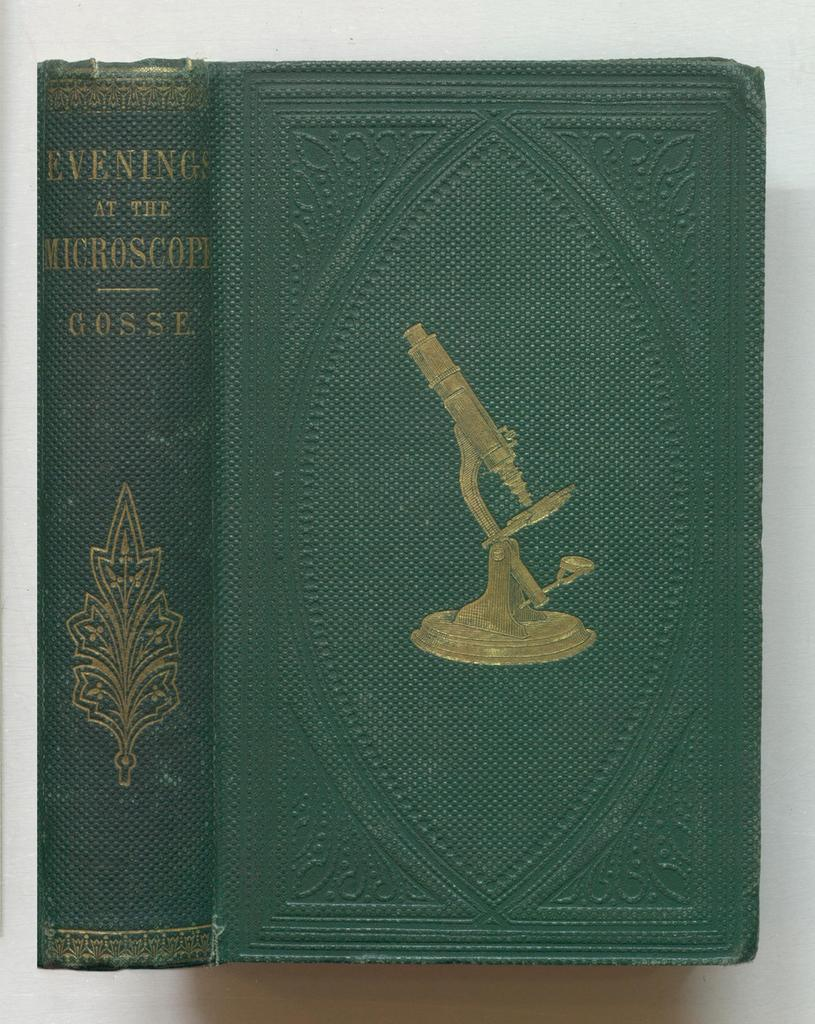<image>
Write a terse but informative summary of the picture. A green book titled, "Evening at the Microscope." 